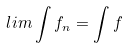Convert formula to latex. <formula><loc_0><loc_0><loc_500><loc_500>l i m \int f _ { n } = \int f</formula> 